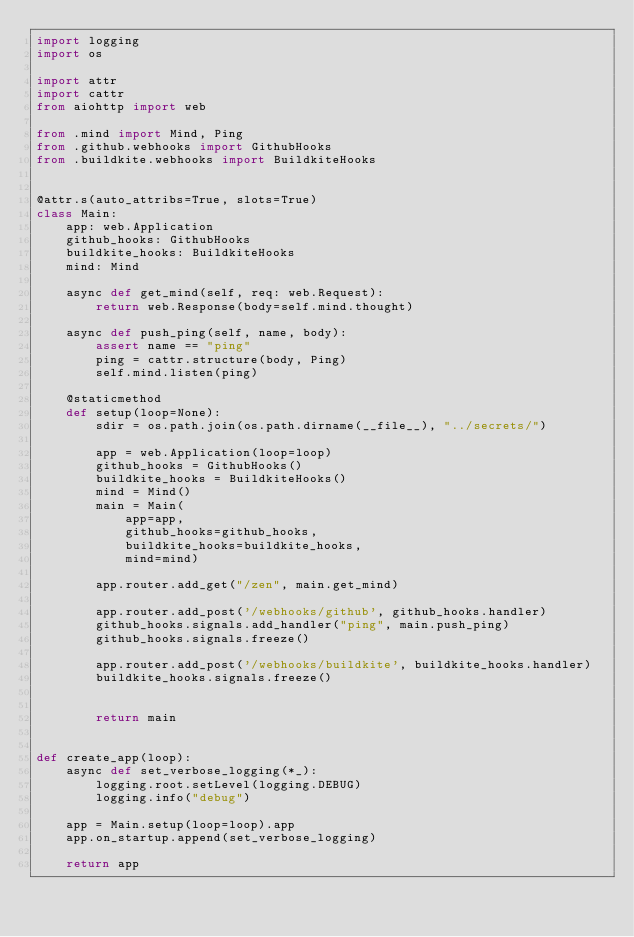<code> <loc_0><loc_0><loc_500><loc_500><_Python_>import logging
import os

import attr
import cattr
from aiohttp import web

from .mind import Mind, Ping
from .github.webhooks import GithubHooks
from .buildkite.webhooks import BuildkiteHooks


@attr.s(auto_attribs=True, slots=True)
class Main:
    app: web.Application
    github_hooks: GithubHooks
    buildkite_hooks: BuildkiteHooks
    mind: Mind

    async def get_mind(self, req: web.Request):
        return web.Response(body=self.mind.thought)

    async def push_ping(self, name, body):
        assert name == "ping"
        ping = cattr.structure(body, Ping)
        self.mind.listen(ping)

    @staticmethod
    def setup(loop=None):
        sdir = os.path.join(os.path.dirname(__file__), "../secrets/")

        app = web.Application(loop=loop)
        github_hooks = GithubHooks()
        buildkite_hooks = BuildkiteHooks()
        mind = Mind()
        main = Main(
            app=app,
            github_hooks=github_hooks,
            buildkite_hooks=buildkite_hooks,
            mind=mind)

        app.router.add_get("/zen", main.get_mind)

        app.router.add_post('/webhooks/github', github_hooks.handler)
        github_hooks.signals.add_handler("ping", main.push_ping)
        github_hooks.signals.freeze()

        app.router.add_post('/webhooks/buildkite', buildkite_hooks.handler)
        buildkite_hooks.signals.freeze()


        return main


def create_app(loop):
    async def set_verbose_logging(*_):
        logging.root.setLevel(logging.DEBUG)
        logging.info("debug")

    app = Main.setup(loop=loop).app
    app.on_startup.append(set_verbose_logging)

    return app
</code> 